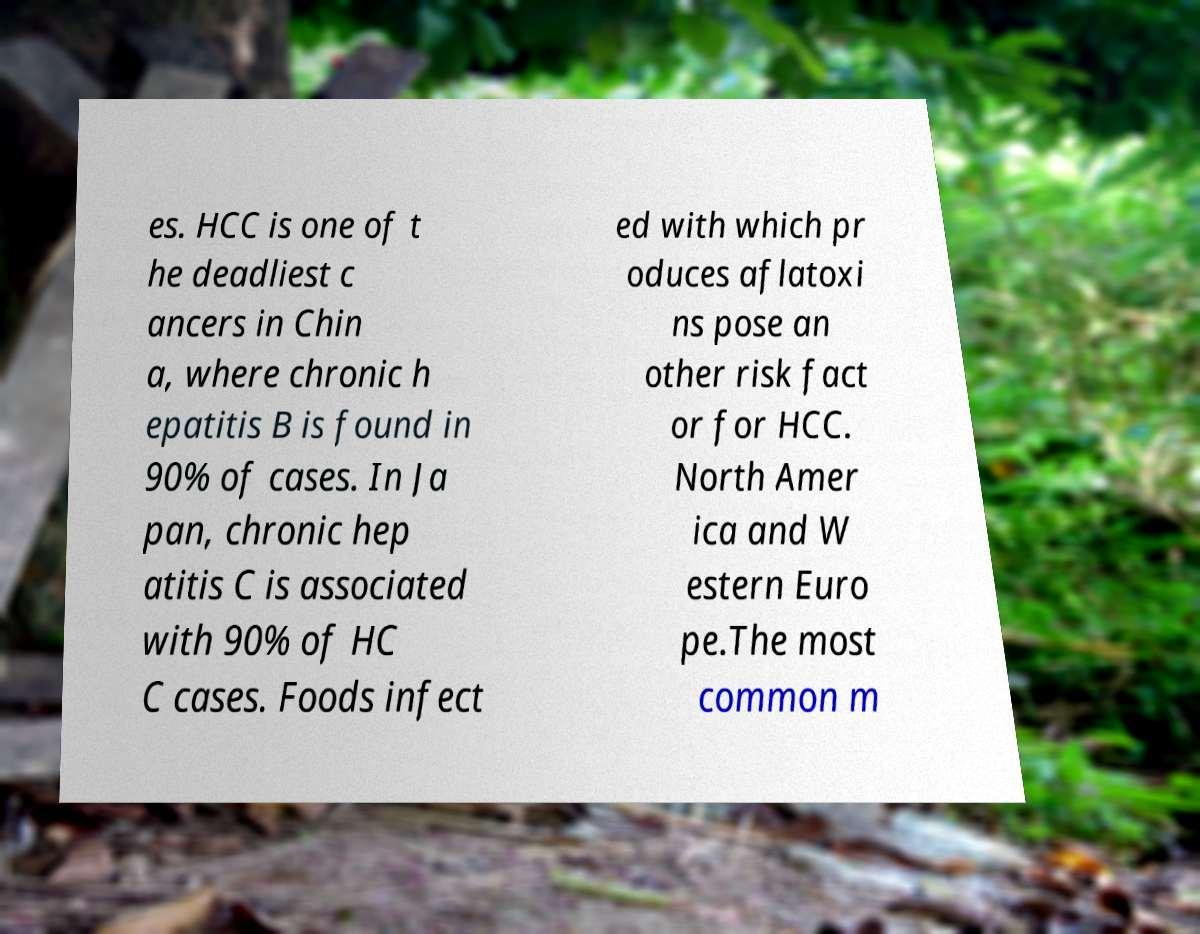I need the written content from this picture converted into text. Can you do that? es. HCC is one of t he deadliest c ancers in Chin a, where chronic h epatitis B is found in 90% of cases. In Ja pan, chronic hep atitis C is associated with 90% of HC C cases. Foods infect ed with which pr oduces aflatoxi ns pose an other risk fact or for HCC. North Amer ica and W estern Euro pe.The most common m 